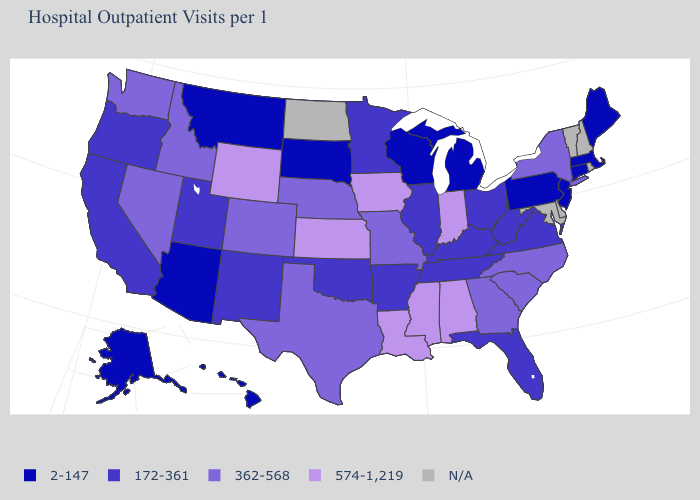Name the states that have a value in the range 172-361?
Concise answer only. Arkansas, California, Florida, Illinois, Kentucky, Minnesota, New Mexico, Ohio, Oklahoma, Oregon, Tennessee, Utah, Virginia, West Virginia. Name the states that have a value in the range 2-147?
Quick response, please. Alaska, Arizona, Connecticut, Hawaii, Maine, Massachusetts, Michigan, Montana, New Jersey, Pennsylvania, South Dakota, Wisconsin. What is the value of Pennsylvania?
Concise answer only. 2-147. How many symbols are there in the legend?
Concise answer only. 5. Does Massachusetts have the lowest value in the Northeast?
Quick response, please. Yes. Which states have the lowest value in the West?
Short answer required. Alaska, Arizona, Hawaii, Montana. Does Pennsylvania have the lowest value in the USA?
Keep it brief. Yes. What is the value of New York?
Be succinct. 362-568. Name the states that have a value in the range 172-361?
Give a very brief answer. Arkansas, California, Florida, Illinois, Kentucky, Minnesota, New Mexico, Ohio, Oklahoma, Oregon, Tennessee, Utah, Virginia, West Virginia. What is the highest value in the USA?
Short answer required. 574-1,219. Does Washington have the lowest value in the West?
Keep it brief. No. Does Nebraska have the lowest value in the MidWest?
Quick response, please. No. Does Minnesota have the highest value in the USA?
Give a very brief answer. No. Name the states that have a value in the range 574-1,219?
Be succinct. Alabama, Indiana, Iowa, Kansas, Louisiana, Mississippi, Wyoming. 